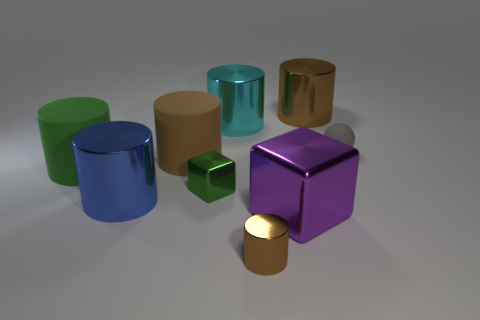Subtract all purple blocks. How many brown cylinders are left? 3 Subtract all large blue shiny cylinders. How many cylinders are left? 5 Subtract all blue cylinders. How many cylinders are left? 5 Subtract 1 cylinders. How many cylinders are left? 5 Subtract all cyan cylinders. Subtract all green balls. How many cylinders are left? 5 Subtract all balls. How many objects are left? 8 Subtract 0 brown balls. How many objects are left? 9 Subtract all balls. Subtract all blue objects. How many objects are left? 7 Add 7 big green rubber cylinders. How many big green rubber cylinders are left? 8 Add 5 cyan shiny objects. How many cyan shiny objects exist? 6 